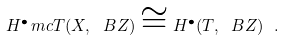Convert formula to latex. <formula><loc_0><loc_0><loc_500><loc_500>H ^ { \bullet } _ { \ } m c T ( X , \ B Z ) \cong H ^ { \bullet } ( T , \ B Z ) \ .</formula> 